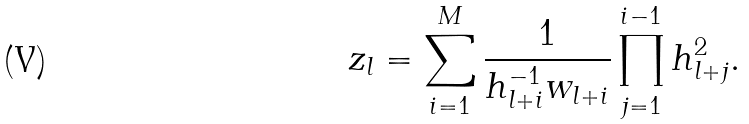Convert formula to latex. <formula><loc_0><loc_0><loc_500><loc_500>z _ { l } = \sum _ { i = 1 } ^ { M } \frac { 1 } { h _ { l + i } ^ { - 1 } w _ { l + i } } \prod _ { j = 1 } ^ { i - 1 } h _ { l + j } ^ { 2 } .</formula> 